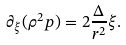<formula> <loc_0><loc_0><loc_500><loc_500>\partial _ { \xi } ( \rho ^ { 2 } p ) = 2 \frac { \Delta } { r ^ { 2 } } \xi .</formula> 